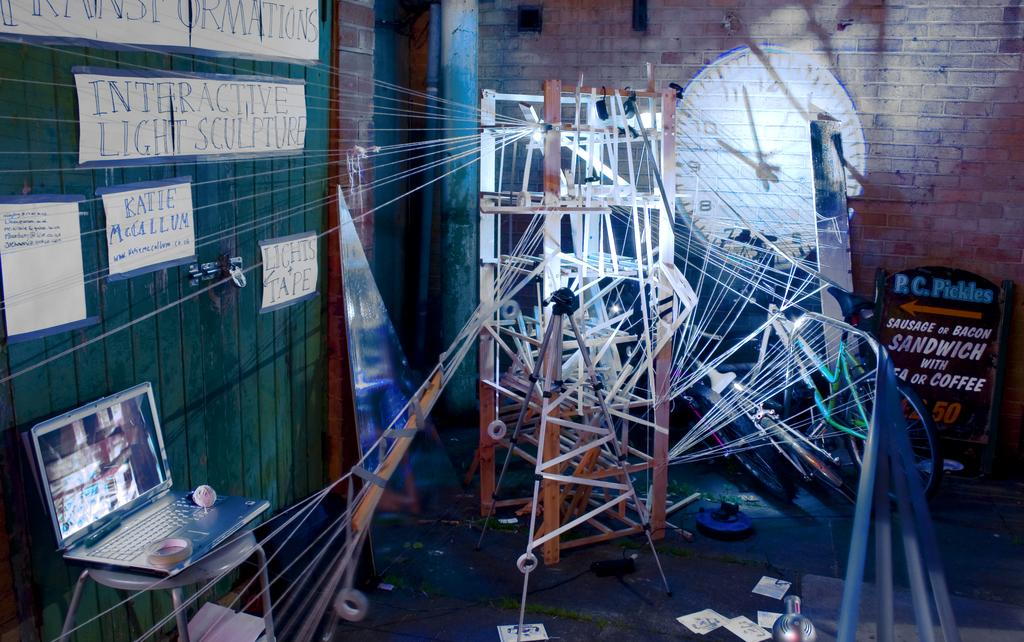<image>
Provide a brief description of the given image. An interactive light sculpture which is controlled by a laptop computer. 